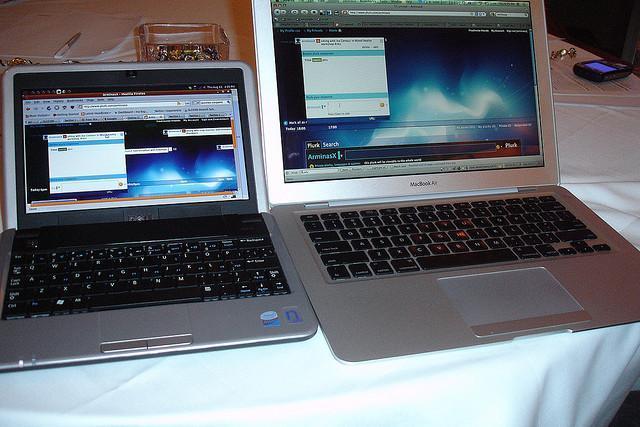How many windows are open on the computer screen?
Give a very brief answer. 2. How many laptops are there?
Give a very brief answer. 2. 